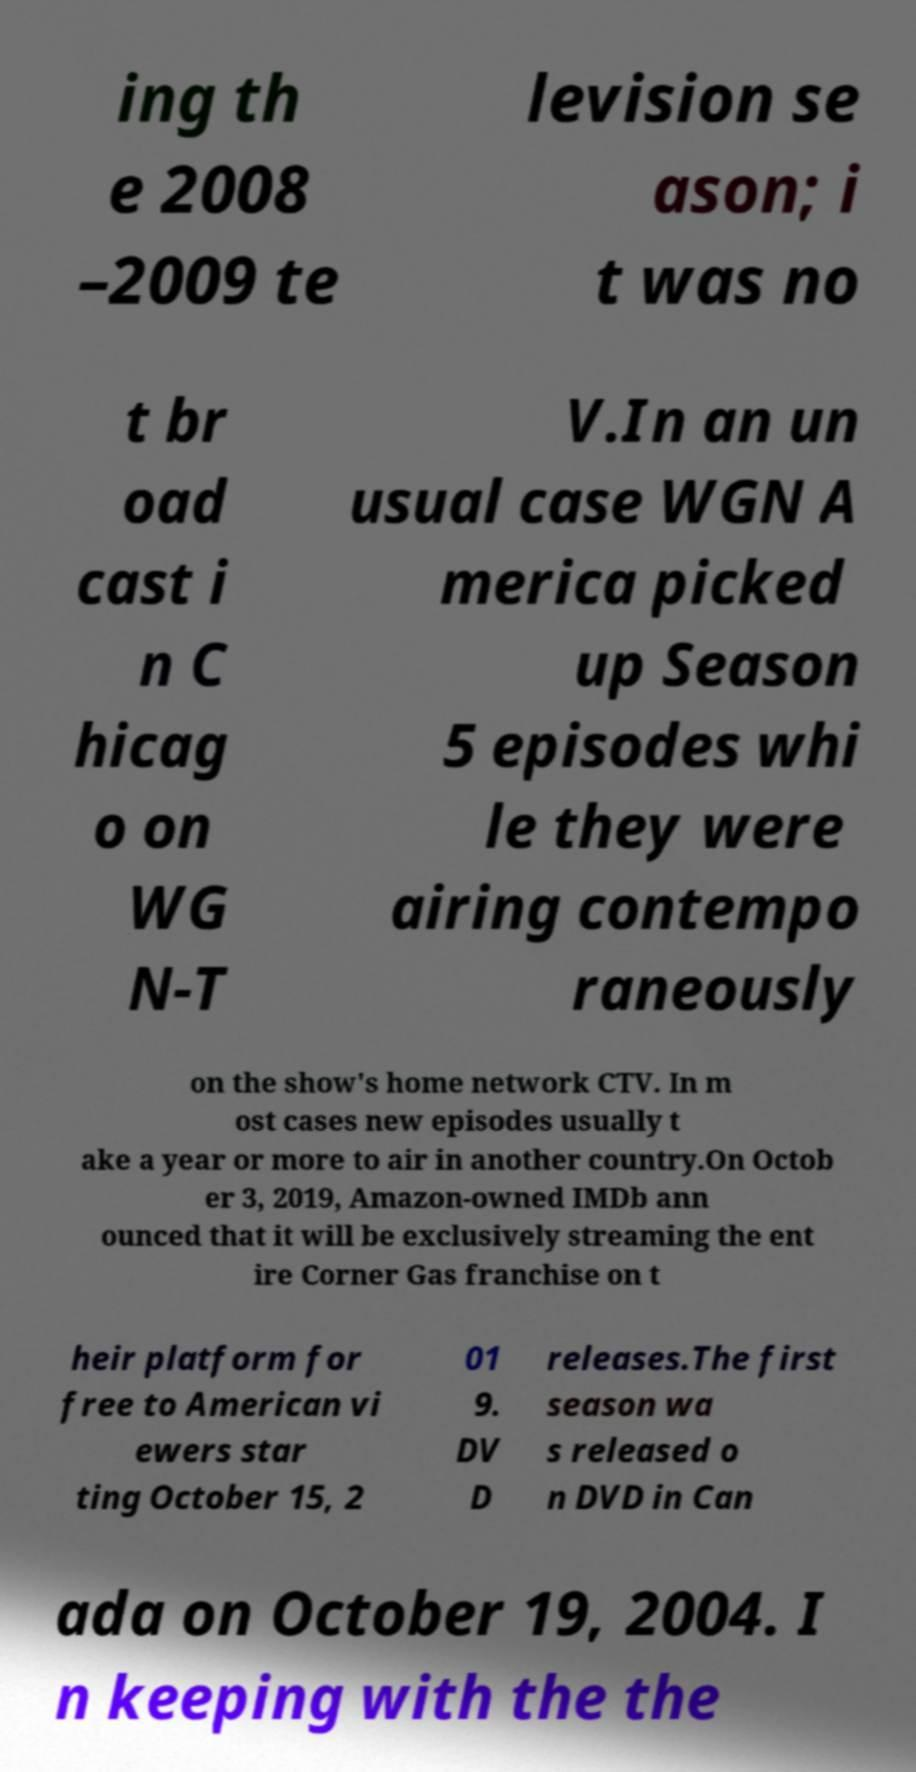What messages or text are displayed in this image? I need them in a readable, typed format. ing th e 2008 –2009 te levision se ason; i t was no t br oad cast i n C hicag o on WG N-T V.In an un usual case WGN A merica picked up Season 5 episodes whi le they were airing contempo raneously on the show's home network CTV. In m ost cases new episodes usually t ake a year or more to air in another country.On Octob er 3, 2019, Amazon-owned IMDb ann ounced that it will be exclusively streaming the ent ire Corner Gas franchise on t heir platform for free to American vi ewers star ting October 15, 2 01 9. DV D releases.The first season wa s released o n DVD in Can ada on October 19, 2004. I n keeping with the the 